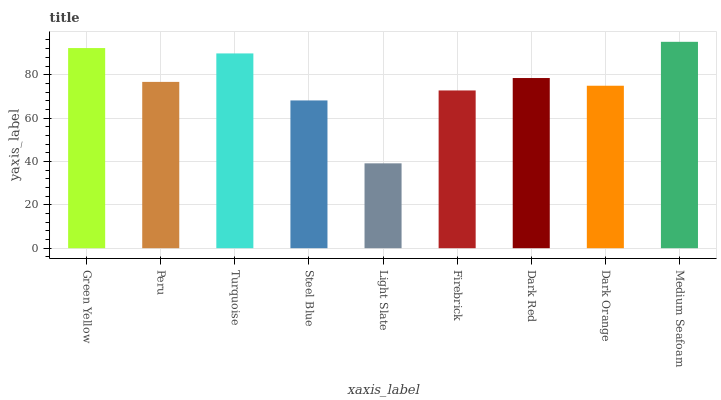Is Light Slate the minimum?
Answer yes or no. Yes. Is Medium Seafoam the maximum?
Answer yes or no. Yes. Is Peru the minimum?
Answer yes or no. No. Is Peru the maximum?
Answer yes or no. No. Is Green Yellow greater than Peru?
Answer yes or no. Yes. Is Peru less than Green Yellow?
Answer yes or no. Yes. Is Peru greater than Green Yellow?
Answer yes or no. No. Is Green Yellow less than Peru?
Answer yes or no. No. Is Peru the high median?
Answer yes or no. Yes. Is Peru the low median?
Answer yes or no. Yes. Is Steel Blue the high median?
Answer yes or no. No. Is Steel Blue the low median?
Answer yes or no. No. 